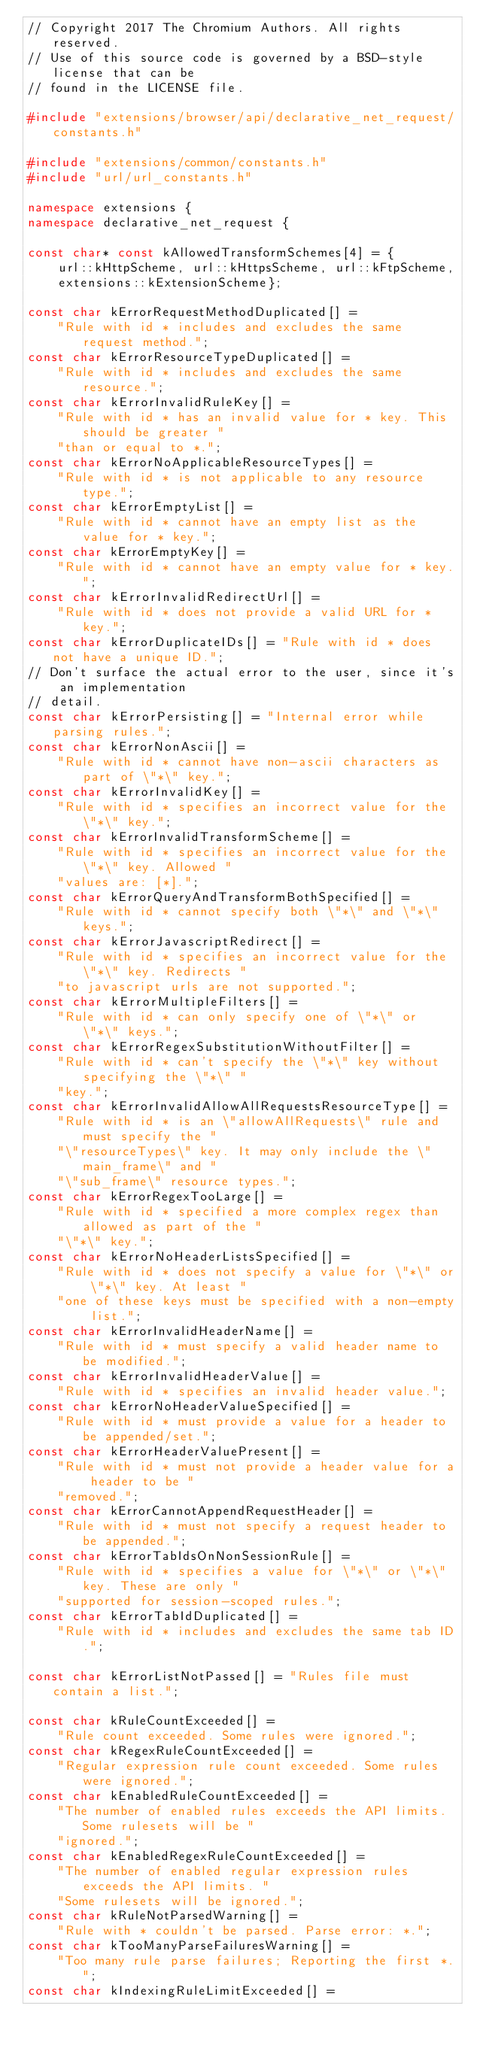Convert code to text. <code><loc_0><loc_0><loc_500><loc_500><_C++_>// Copyright 2017 The Chromium Authors. All rights reserved.
// Use of this source code is governed by a BSD-style license that can be
// found in the LICENSE file.

#include "extensions/browser/api/declarative_net_request/constants.h"

#include "extensions/common/constants.h"
#include "url/url_constants.h"

namespace extensions {
namespace declarative_net_request {

const char* const kAllowedTransformSchemes[4] = {
    url::kHttpScheme, url::kHttpsScheme, url::kFtpScheme,
    extensions::kExtensionScheme};

const char kErrorRequestMethodDuplicated[] =
    "Rule with id * includes and excludes the same request method.";
const char kErrorResourceTypeDuplicated[] =
    "Rule with id * includes and excludes the same resource.";
const char kErrorInvalidRuleKey[] =
    "Rule with id * has an invalid value for * key. This should be greater "
    "than or equal to *.";
const char kErrorNoApplicableResourceTypes[] =
    "Rule with id * is not applicable to any resource type.";
const char kErrorEmptyList[] =
    "Rule with id * cannot have an empty list as the value for * key.";
const char kErrorEmptyKey[] =
    "Rule with id * cannot have an empty value for * key.";
const char kErrorInvalidRedirectUrl[] =
    "Rule with id * does not provide a valid URL for * key.";
const char kErrorDuplicateIDs[] = "Rule with id * does not have a unique ID.";
// Don't surface the actual error to the user, since it's an implementation
// detail.
const char kErrorPersisting[] = "Internal error while parsing rules.";
const char kErrorNonAscii[] =
    "Rule with id * cannot have non-ascii characters as part of \"*\" key.";
const char kErrorInvalidKey[] =
    "Rule with id * specifies an incorrect value for the \"*\" key.";
const char kErrorInvalidTransformScheme[] =
    "Rule with id * specifies an incorrect value for the \"*\" key. Allowed "
    "values are: [*].";
const char kErrorQueryAndTransformBothSpecified[] =
    "Rule with id * cannot specify both \"*\" and \"*\" keys.";
const char kErrorJavascriptRedirect[] =
    "Rule with id * specifies an incorrect value for the \"*\" key. Redirects "
    "to javascript urls are not supported.";
const char kErrorMultipleFilters[] =
    "Rule with id * can only specify one of \"*\" or \"*\" keys.";
const char kErrorRegexSubstitutionWithoutFilter[] =
    "Rule with id * can't specify the \"*\" key without specifying the \"*\" "
    "key.";
const char kErrorInvalidAllowAllRequestsResourceType[] =
    "Rule with id * is an \"allowAllRequests\" rule and must specify the "
    "\"resourceTypes\" key. It may only include the \"main_frame\" and "
    "\"sub_frame\" resource types.";
const char kErrorRegexTooLarge[] =
    "Rule with id * specified a more complex regex than allowed as part of the "
    "\"*\" key.";
const char kErrorNoHeaderListsSpecified[] =
    "Rule with id * does not specify a value for \"*\" or \"*\" key. At least "
    "one of these keys must be specified with a non-empty list.";
const char kErrorInvalidHeaderName[] =
    "Rule with id * must specify a valid header name to be modified.";
const char kErrorInvalidHeaderValue[] =
    "Rule with id * specifies an invalid header value.";
const char kErrorNoHeaderValueSpecified[] =
    "Rule with id * must provide a value for a header to be appended/set.";
const char kErrorHeaderValuePresent[] =
    "Rule with id * must not provide a header value for a header to be "
    "removed.";
const char kErrorCannotAppendRequestHeader[] =
    "Rule with id * must not specify a request header to be appended.";
const char kErrorTabIdsOnNonSessionRule[] =
    "Rule with id * specifies a value for \"*\" or \"*\" key. These are only "
    "supported for session-scoped rules.";
const char kErrorTabIdDuplicated[] =
    "Rule with id * includes and excludes the same tab ID.";

const char kErrorListNotPassed[] = "Rules file must contain a list.";

const char kRuleCountExceeded[] =
    "Rule count exceeded. Some rules were ignored.";
const char kRegexRuleCountExceeded[] =
    "Regular expression rule count exceeded. Some rules were ignored.";
const char kEnabledRuleCountExceeded[] =
    "The number of enabled rules exceeds the API limits. Some rulesets will be "
    "ignored.";
const char kEnabledRegexRuleCountExceeded[] =
    "The number of enabled regular expression rules exceeds the API limits. "
    "Some rulesets will be ignored.";
const char kRuleNotParsedWarning[] =
    "Rule with * couldn't be parsed. Parse error: *.";
const char kTooManyParseFailuresWarning[] =
    "Too many rule parse failures; Reporting the first *.";
const char kIndexingRuleLimitExceeded[] =</code> 